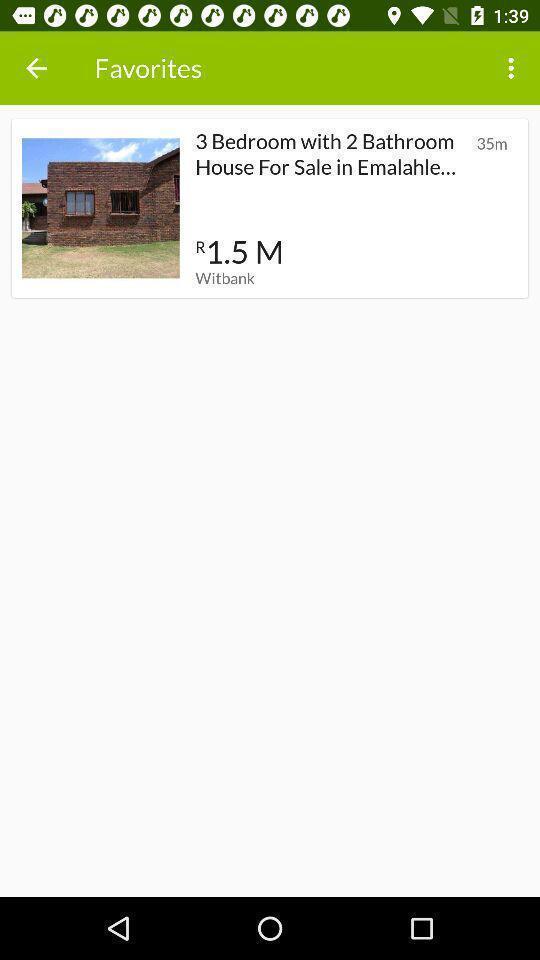Tell me what you see in this picture. Page displaying with favorite properties list. 